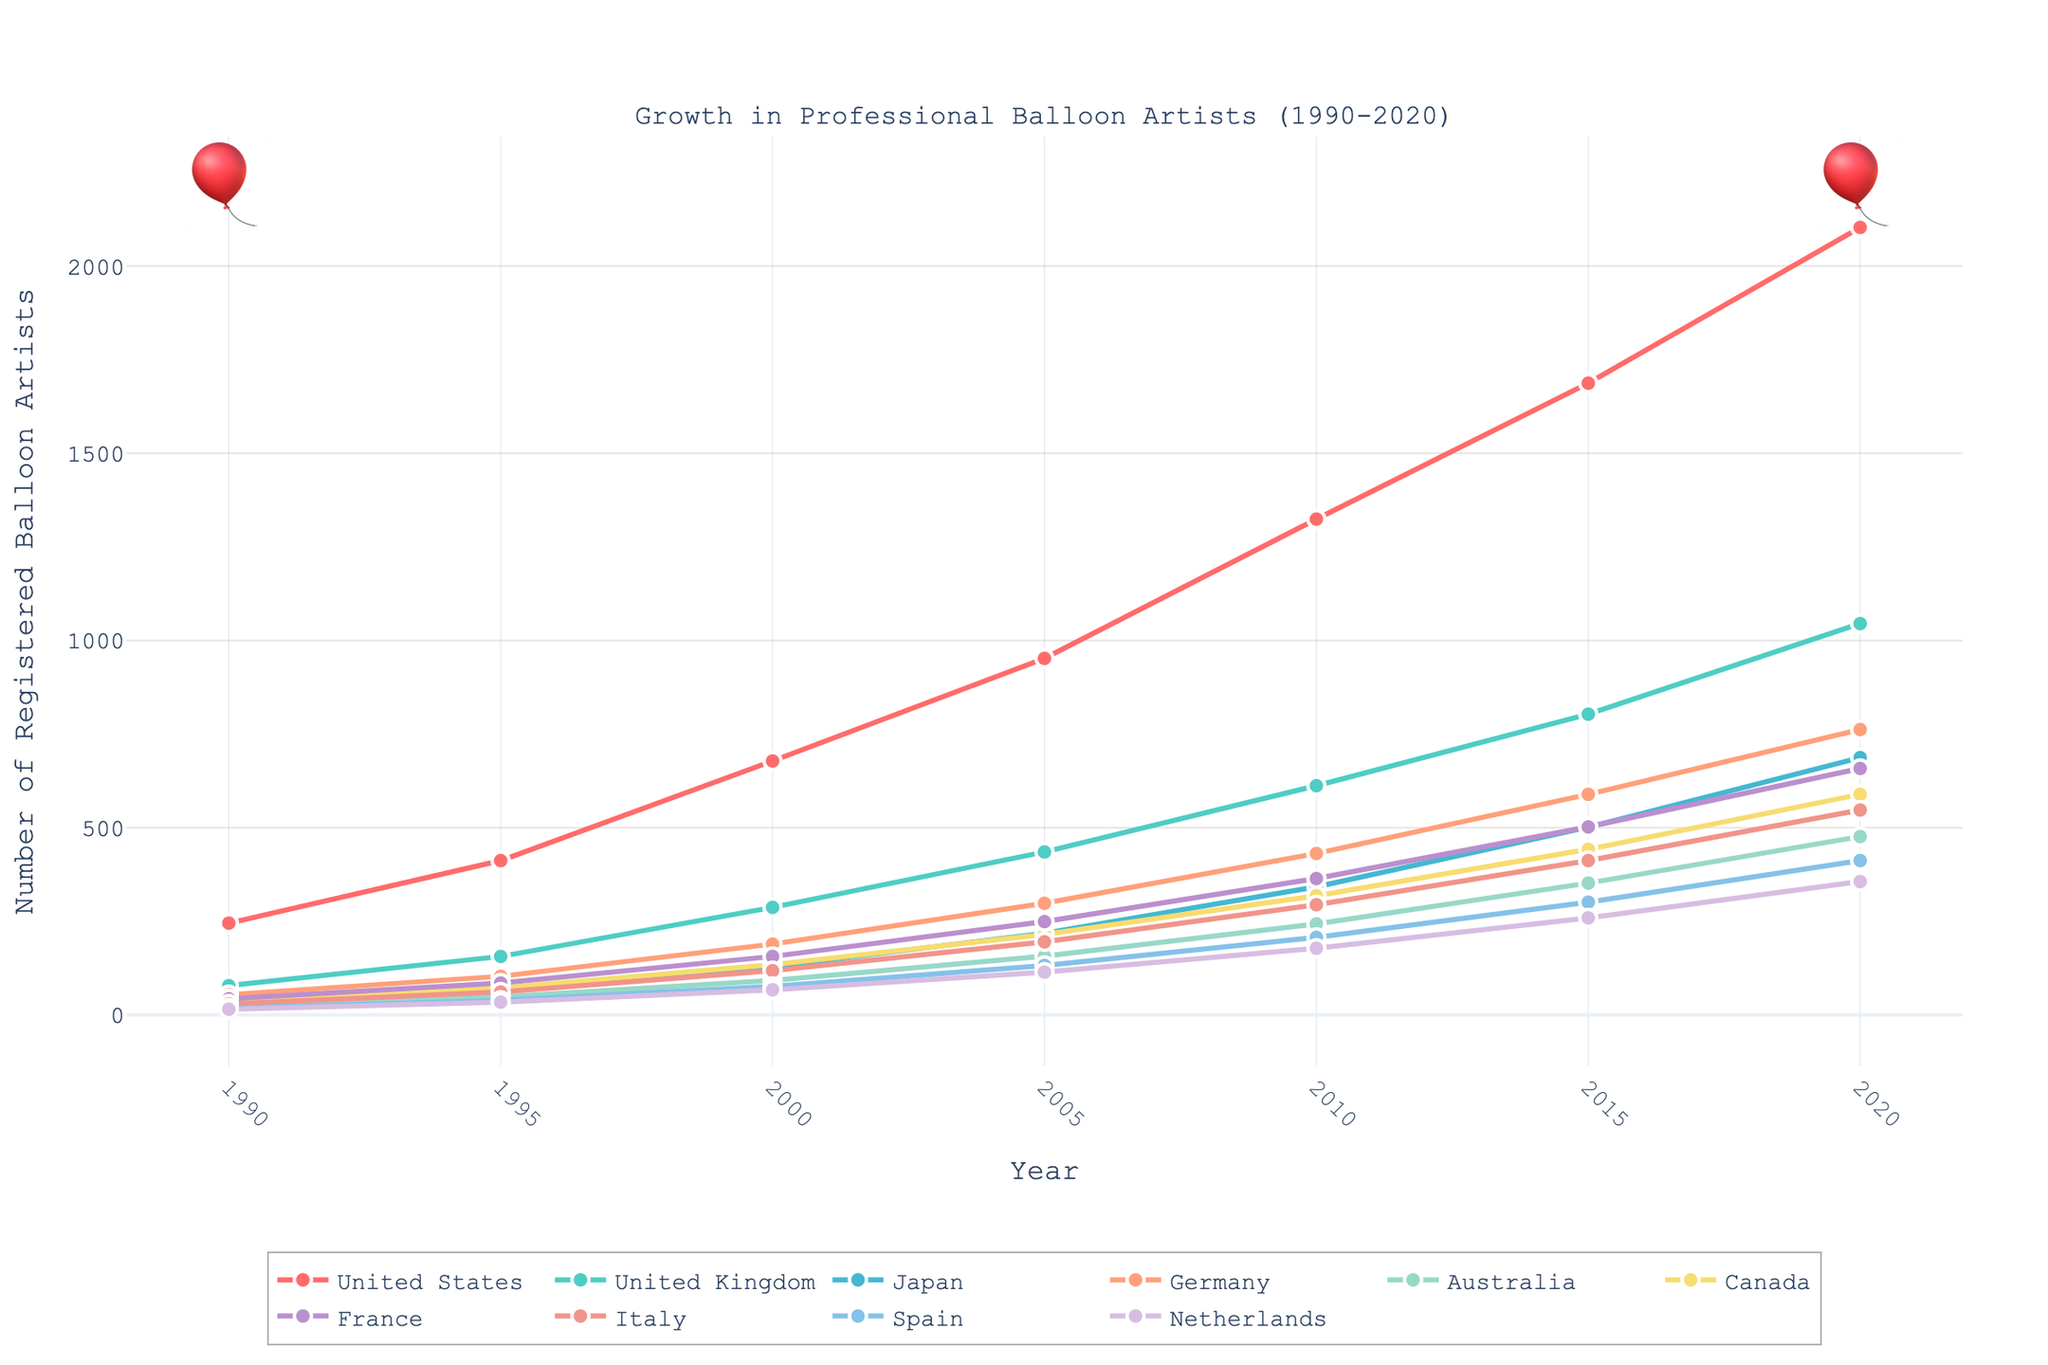What is the total number of professional balloon artists in the United States in 2020? Look at the 2020 data point for the United States and note the value.
Answer: 2103 Between which years did the United Kingdom see the highest increase in the number of registered balloon artists? Look at the slope of the line for the United Kingdom. The steepest slope indicates the greatest increase. The increase from 1990 to 1995 is the steepest.
Answer: 1990 to 1995 By how much did the number of professional balloon artists in Japan grow from 2015 to 2020? Observe the values for Japan in 2015 (501) and 2020 (687). Subtract the 2015 value from the 2020 value: 687 - 501 = 186.
Answer: 186 Which country had the least number of professional balloon artists in 1990, and how many did it have? Compare the 1990 values across all countries. The Netherlands has the smallest number with 15.
Answer: Netherlands, 15 What is the average number of professional balloon artists in Canada from 1990 to 2020? Sum the numbers for Canada across the years (37 + 72 + 134 + 215 + 318 + 442 + 589) and divide by the number of years (7). (37 + 72 + 134 + 215 + 318 + 442 + 589) / 7 = 258.14
Answer: 258.14 How much higher is the number of professional balloon artists in France compared to Italy in 2020? Look at the 2020 values for France (658) and Italy (547). Subtract the number for Italy from the number for France: 658 - 547 = 111.
Answer: 111 Which year saw the highest number of professional balloon artists in Germany? Scan the German data points across the years and identify the year with the largest value, which is 2020 with 762.
Answer: 2020 What was the percentage increase in the number of professional balloon artists in Australia from 2000 to 2020? Find the numbers for Australia in 2000 (92) and 2020 (476). Use the formula (New Value - Old Value) / Old Value * 100 = Percentage Increase. (476 - 92) / 92 * 100 ≈ 417.39%
Answer: 417.39% Which countries have more than 1000 professional balloon artists in 2020? Check the 2020 values for all countries and list those exceeding 1000: United States (2103) and United Kingdom (1045).
Answer: United States, United Kingdom 